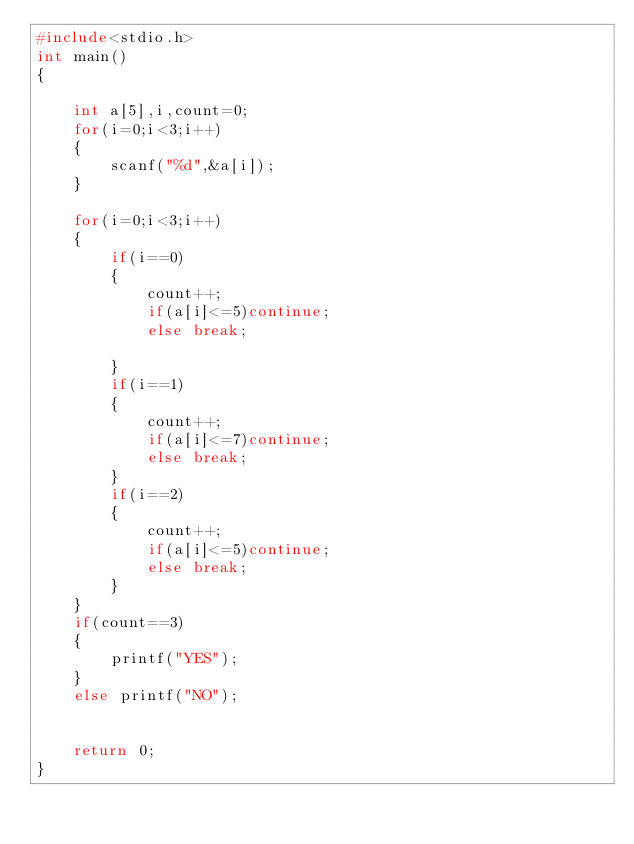<code> <loc_0><loc_0><loc_500><loc_500><_C_>#include<stdio.h>
int main()
{
	
	int a[5],i,count=0;
	for(i=0;i<3;i++)
	{
		scanf("%d",&a[i]);		
	}	

	for(i=0;i<3;i++)
	{
		if(i==0)
		{
			count++;
			if(a[i]<=5)continue;
			else break;
		
		}
		if(i==1)
		{
			count++;
			if(a[i]<=7)continue;
			else break;
		}
		if(i==2)
		{
			count++;
			if(a[i]<=5)continue;
			else break;
		}
	}
	if(count==3)
	{
		printf("YES");
	}
	else printf("NO");
		
		
	return 0;
}</code> 